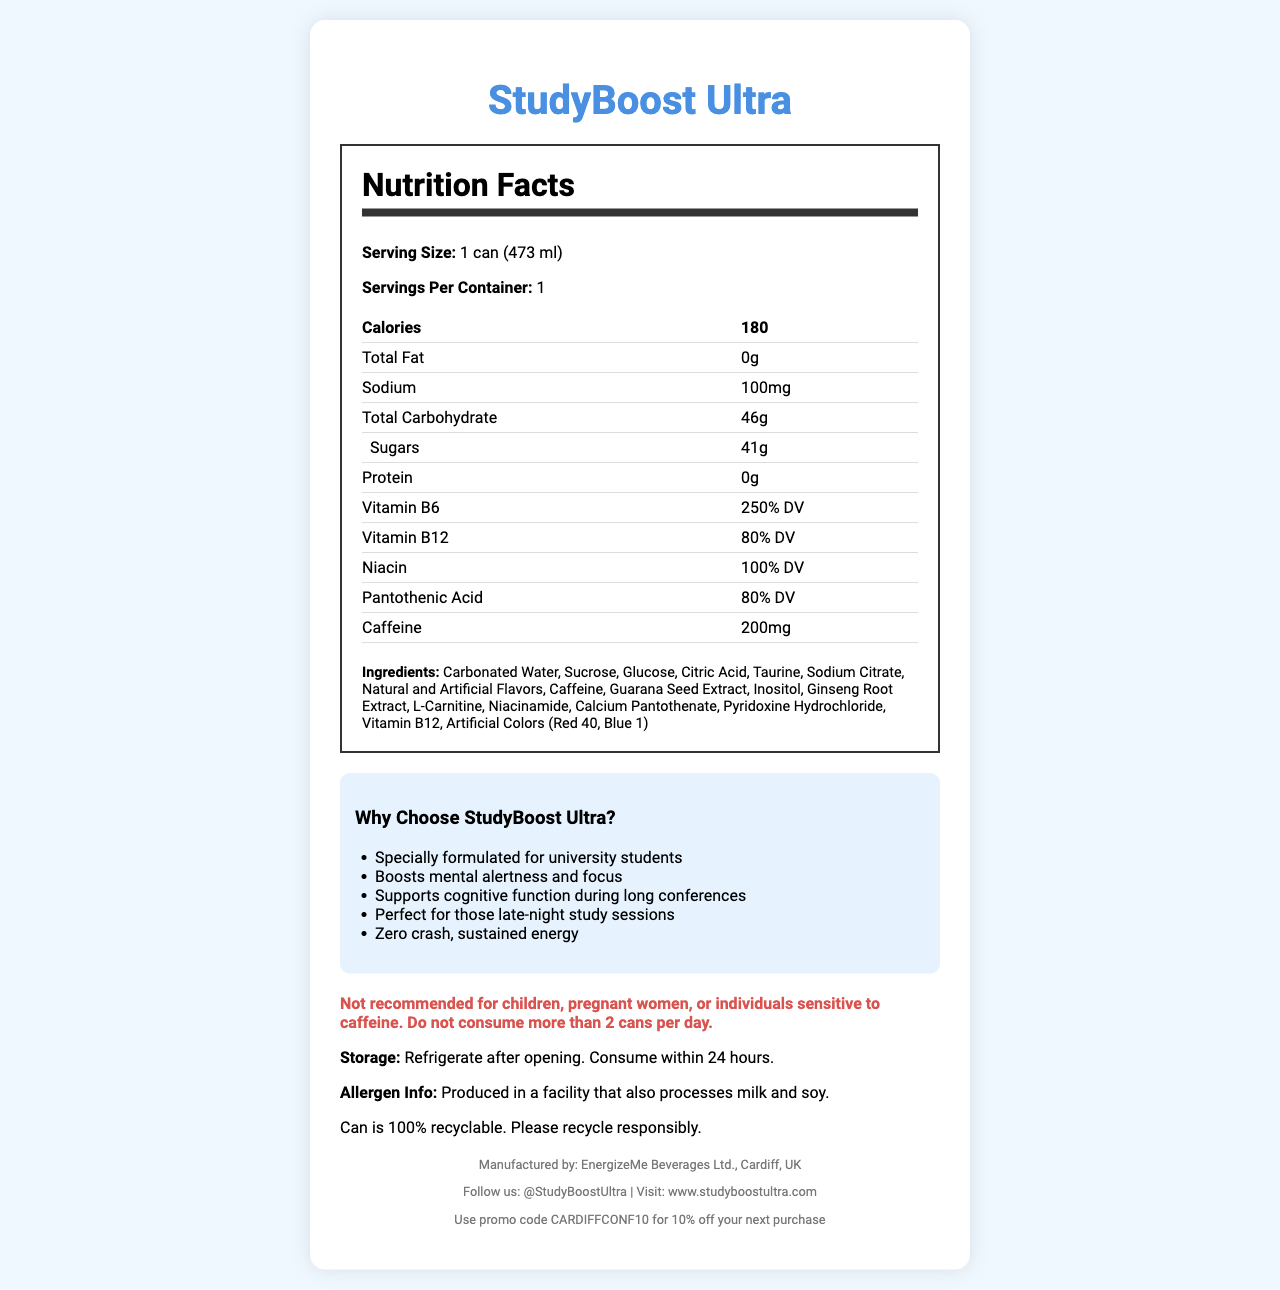What is the serving size for StudyBoost Ultra? The serving size is clearly mentioned in the document as "1 can (473 ml)".
Answer: 1 can (473 ml) What is the calorie count for one can of StudyBoost Ultra? The document states that one can contains 180 calories.
Answer: 180 How much caffeine does one serving of StudyBoost Ultra contain? The document lists caffeine content as 200mg per serving.
Answer: 200mg Which company manufactures StudyBoost Ultra? The manufacturer information in the footer indicates that EnergizeMe Beverages Ltd. in Cardiff, UK is responsible for producing StudyBoost Ultra.
Answer: EnergizeMe Beverages Ltd., Cardiff, UK What are the primary sugars used in StudyBoost Ultra? The ingredients section lists sucrose and glucose as the primary sugars.
Answer: Sucrose and Glucose How many grams of sugar are in one can of StudyBoost Ultra? The total sugars are listed as 41 grams per serving.
Answer: 41g What vitamin has the highest daily value percentage in StudyBoost Ultra? A. Vitamin B6 B. Vitamin B12 C. Niacin D. Pantothenic Acid The nutrition label shows that Vitamin B6 has 250% DV, which is higher than the other listed vitamins.
Answer: A. Vitamin B6 What is the sodium content per serving of StudyBoost Ultra? A. 50mg B. 100mg C. 150mg D. 200mg The document lists the sodium content as 100mg per serving.
Answer: B. 100mg Is StudyBoost Ultra suitable for children? The warning specifies that the product is not recommended for children, pregnant women, or individuals sensitive to caffeine.
Answer: No Summarize the main idea of the StudyBoost Ultra document. The document provides comprehensive information about StudyBoost Ultra, including its nutritional contents, unique selling points, and safety instructions.
Answer: StudyBoost Ultra is an energy drink specifically formulated for university students to boost mental alertness, focus, and support cognitive function. Each can contains 180 calories, 200mg of caffeine, along with various vitamins and other active ingredients. The document highlights its nutritional facts, ingredients, manufacturer, warnings, and promotional claims. What are the marketing claims mentioned for StudyBoost Ultra? The marketing claims listed under "Why Choose StudyBoost Ultra?" detail these points aimed at university students.
Answer: Boosts mental alertness and focus, supports cognitive function during long conferences, perfect for late-night study sessions, zero crash, sustained energy Is StudyBoost Ultra low in calories? The document states that one can contains 180 calories, which is relatively high for an energy drink.
Answer: No What is the recommended storage condition for StudyBoost Ultra after opening? The storage instructions in the document specify refrigeration after opening and consumption within 24 hours.
Answer: Refrigerate after opening. Consume within 24 hours. Does StudyBoost Ultra contain any artificial colors? The ingredients list includes Artificial Colors (Red 40, Blue 1).
Answer: Yes Does StudyBoost Ultra fit a dairy-free diet? The allergen information says it is produced in a facility that processes milk and soy, but it doesn't clarify the presence or absence of milk in the product itself.
Answer: Cannot be determined What is a notable feature about the packaging of StudyBoost Ultra? The document mentions that the packaging is 100% recyclable.
Answer: The can is 100% recyclable. 